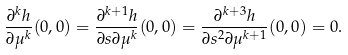<formula> <loc_0><loc_0><loc_500><loc_500>\frac { \partial ^ { k } h } { \partial \mu ^ { k } } ( 0 , 0 ) = \frac { \partial ^ { k + 1 } h } { \partial s \partial \mu ^ { k } } ( 0 , 0 ) = \frac { \partial ^ { k + 3 } h } { \partial s ^ { 2 } \partial \mu ^ { k + 1 } } ( 0 , 0 ) = 0 .</formula> 